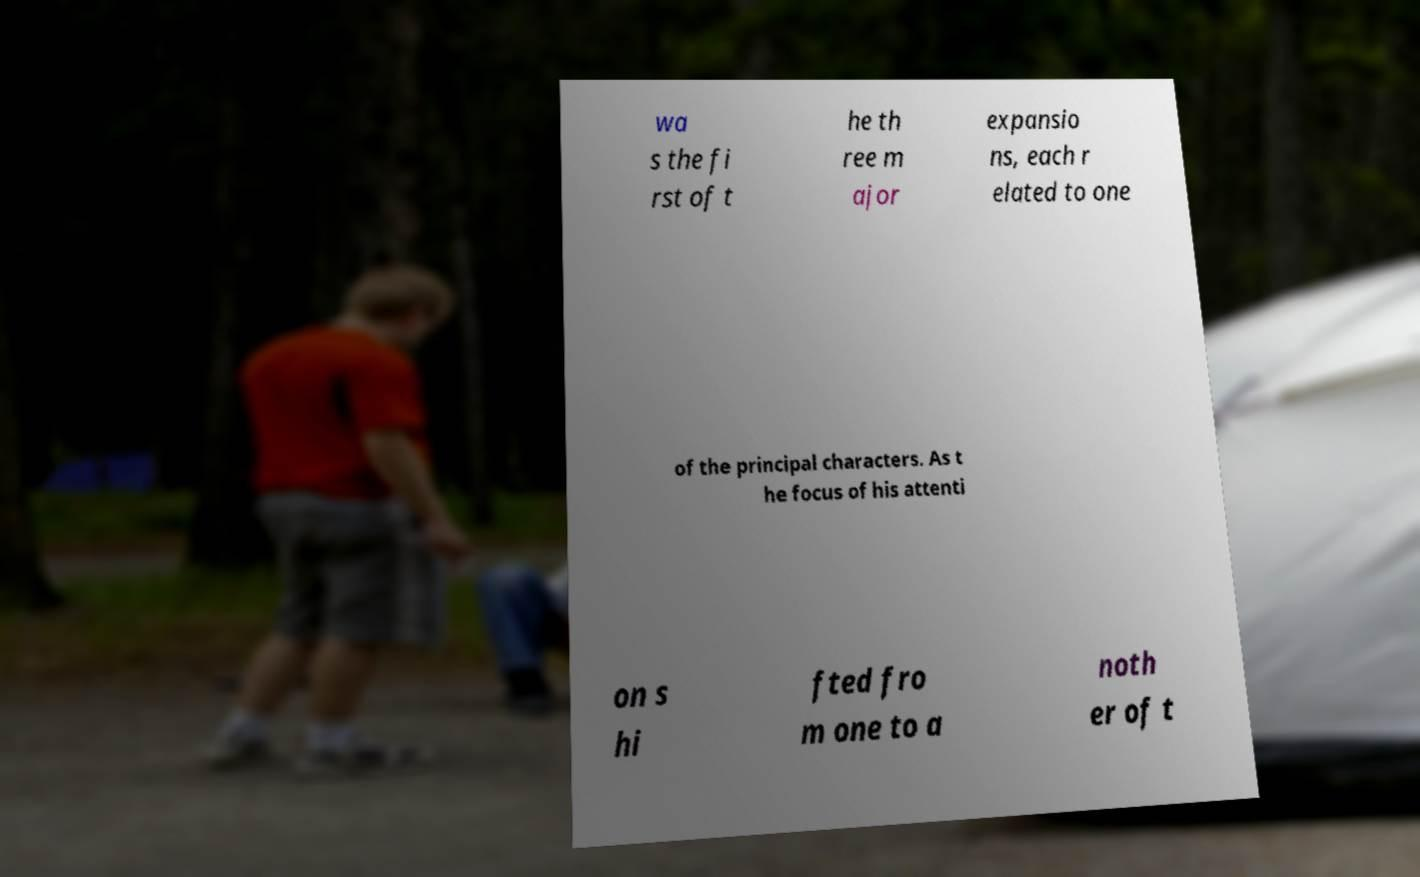Can you read and provide the text displayed in the image?This photo seems to have some interesting text. Can you extract and type it out for me? wa s the fi rst of t he th ree m ajor expansio ns, each r elated to one of the principal characters. As t he focus of his attenti on s hi fted fro m one to a noth er of t 